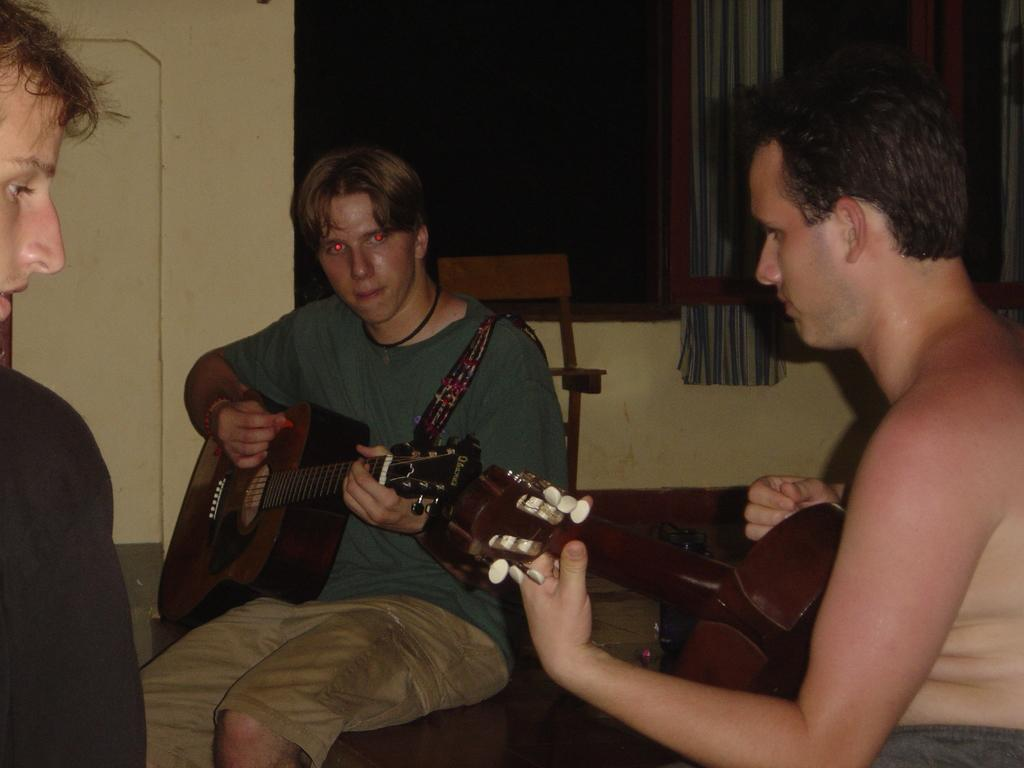How many people are present in the image? There are three people in the image. What are the people doing in the image? The people are sitting on chairs, and two of them are holding and playing guitars. What can be seen in the background of the image? There is a window and a curtain associated with the window in the background. What type of rifle can be seen in the image? There is no rifle present in the image. What is the opinion of the person holding the guitar about the music they are playing? The image does not provide any information about the person's opinion on the music they are playing. 